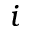<formula> <loc_0><loc_0><loc_500><loc_500>i</formula> 